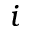<formula> <loc_0><loc_0><loc_500><loc_500>i</formula> 